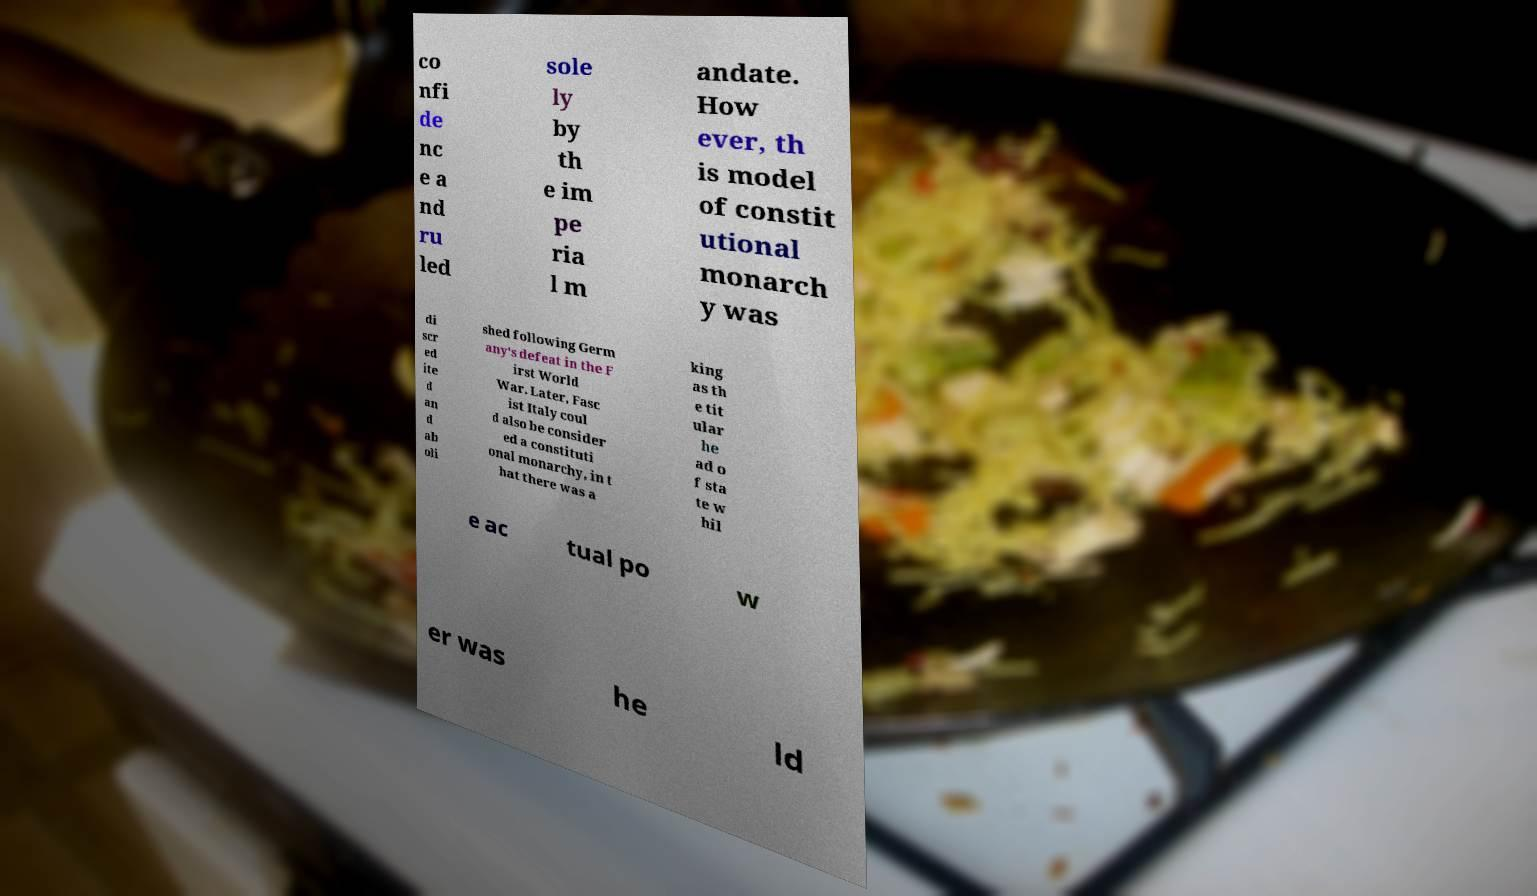Can you accurately transcribe the text from the provided image for me? co nfi de nc e a nd ru led sole ly by th e im pe ria l m andate. How ever, th is model of constit utional monarch y was di scr ed ite d an d ab oli shed following Germ any's defeat in the F irst World War. Later, Fasc ist Italy coul d also be consider ed a constituti onal monarchy, in t hat there was a king as th e tit ular he ad o f sta te w hil e ac tual po w er was he ld 